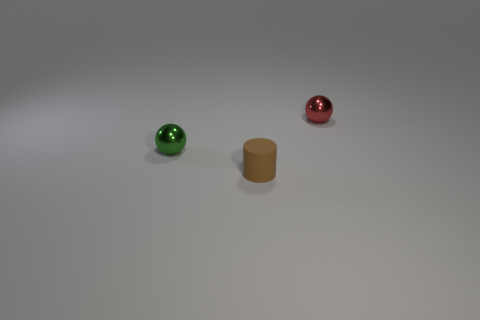Subtract all purple spheres. Subtract all green cylinders. How many spheres are left? 2 Add 1 red shiny things. How many objects exist? 4 Subtract all cylinders. How many objects are left? 2 Subtract all red balls. Subtract all metallic things. How many objects are left? 0 Add 2 brown matte objects. How many brown matte objects are left? 3 Add 1 tiny brown matte cubes. How many tiny brown matte cubes exist? 1 Subtract 0 blue cylinders. How many objects are left? 3 